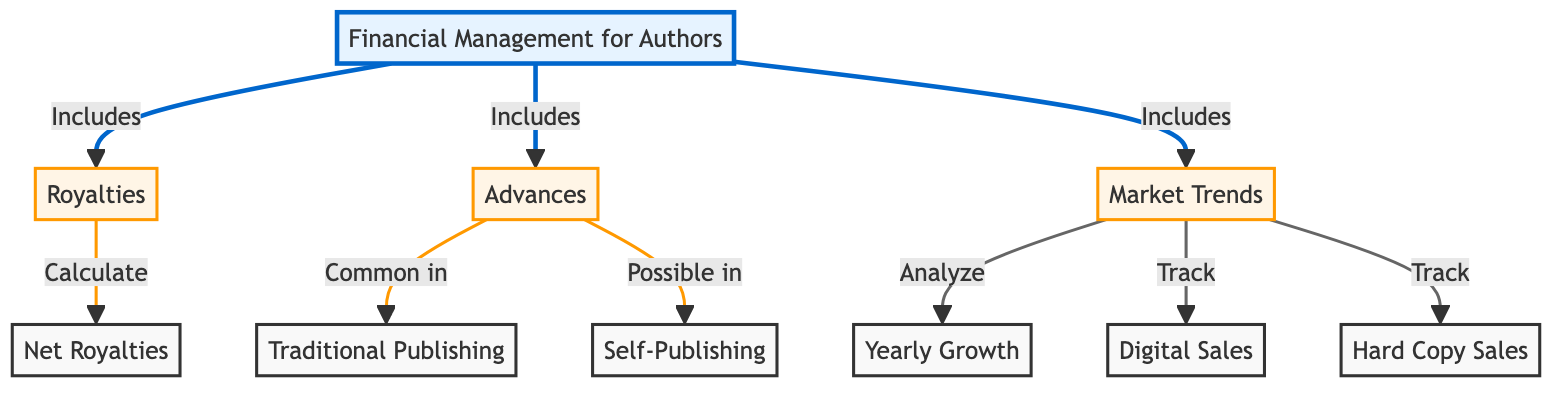What are the three main components included in financial management for authors? The diagram lists three main components: Royalties, Advances, and Market Trends, which are directly linked to the main node labeled 'Financial Management for Authors'.
Answer: Royalties, Advances, Market Trends How many nodes are present in the diagram? By counting each individual entity, there are a total of 10 nodes including the main node and its subcomponents.
Answer: 10 What is calculated from Royalties? The diagram specifies that the output from the Royalties node is 'Net Royalties', showing a direct connection.
Answer: Net Royalties Which publishing method is associated with Advances? The diagram indicates that Advances are 'Common in' Traditional Publishing, linking those two concepts.
Answer: Traditional Publishing What annual measure does the Market Trends analyze? The diagram shows that Market Trends are linked to 'Yearly Growth', indicating that's what is analyzed in this context.
Answer: Yearly Growth How do Market Trends interact with Digital and Hard Copy Sales? Market Trends are illustrated to 'track' both Digital Sales and Hard Copy Sales, indicating an observational relationship with those concepts.
Answer: Track Which node has the strongest relationship with Net Royalties? The most direct relationship evident is between Royalties and Net Royalties, as indicated by a clear directional arrow from Royalties leading to Net Royalties.
Answer: Royalties What are the options for publishers regarding Advances? According to the diagram, Advances can be 'Common in' Traditional Publishing and 'Possible in' Self-Publishing, showing two potential avenues.
Answer: Traditional Publishing, Self-Publishing What do the dashed arrows from Market Trends indicate? The diagram does not include dashed arrows; it uses solid connections to imply direct relationships such as analysis or tracking. This reflects certainty rather than conditional relationships.
Answer: No dashed arrows 